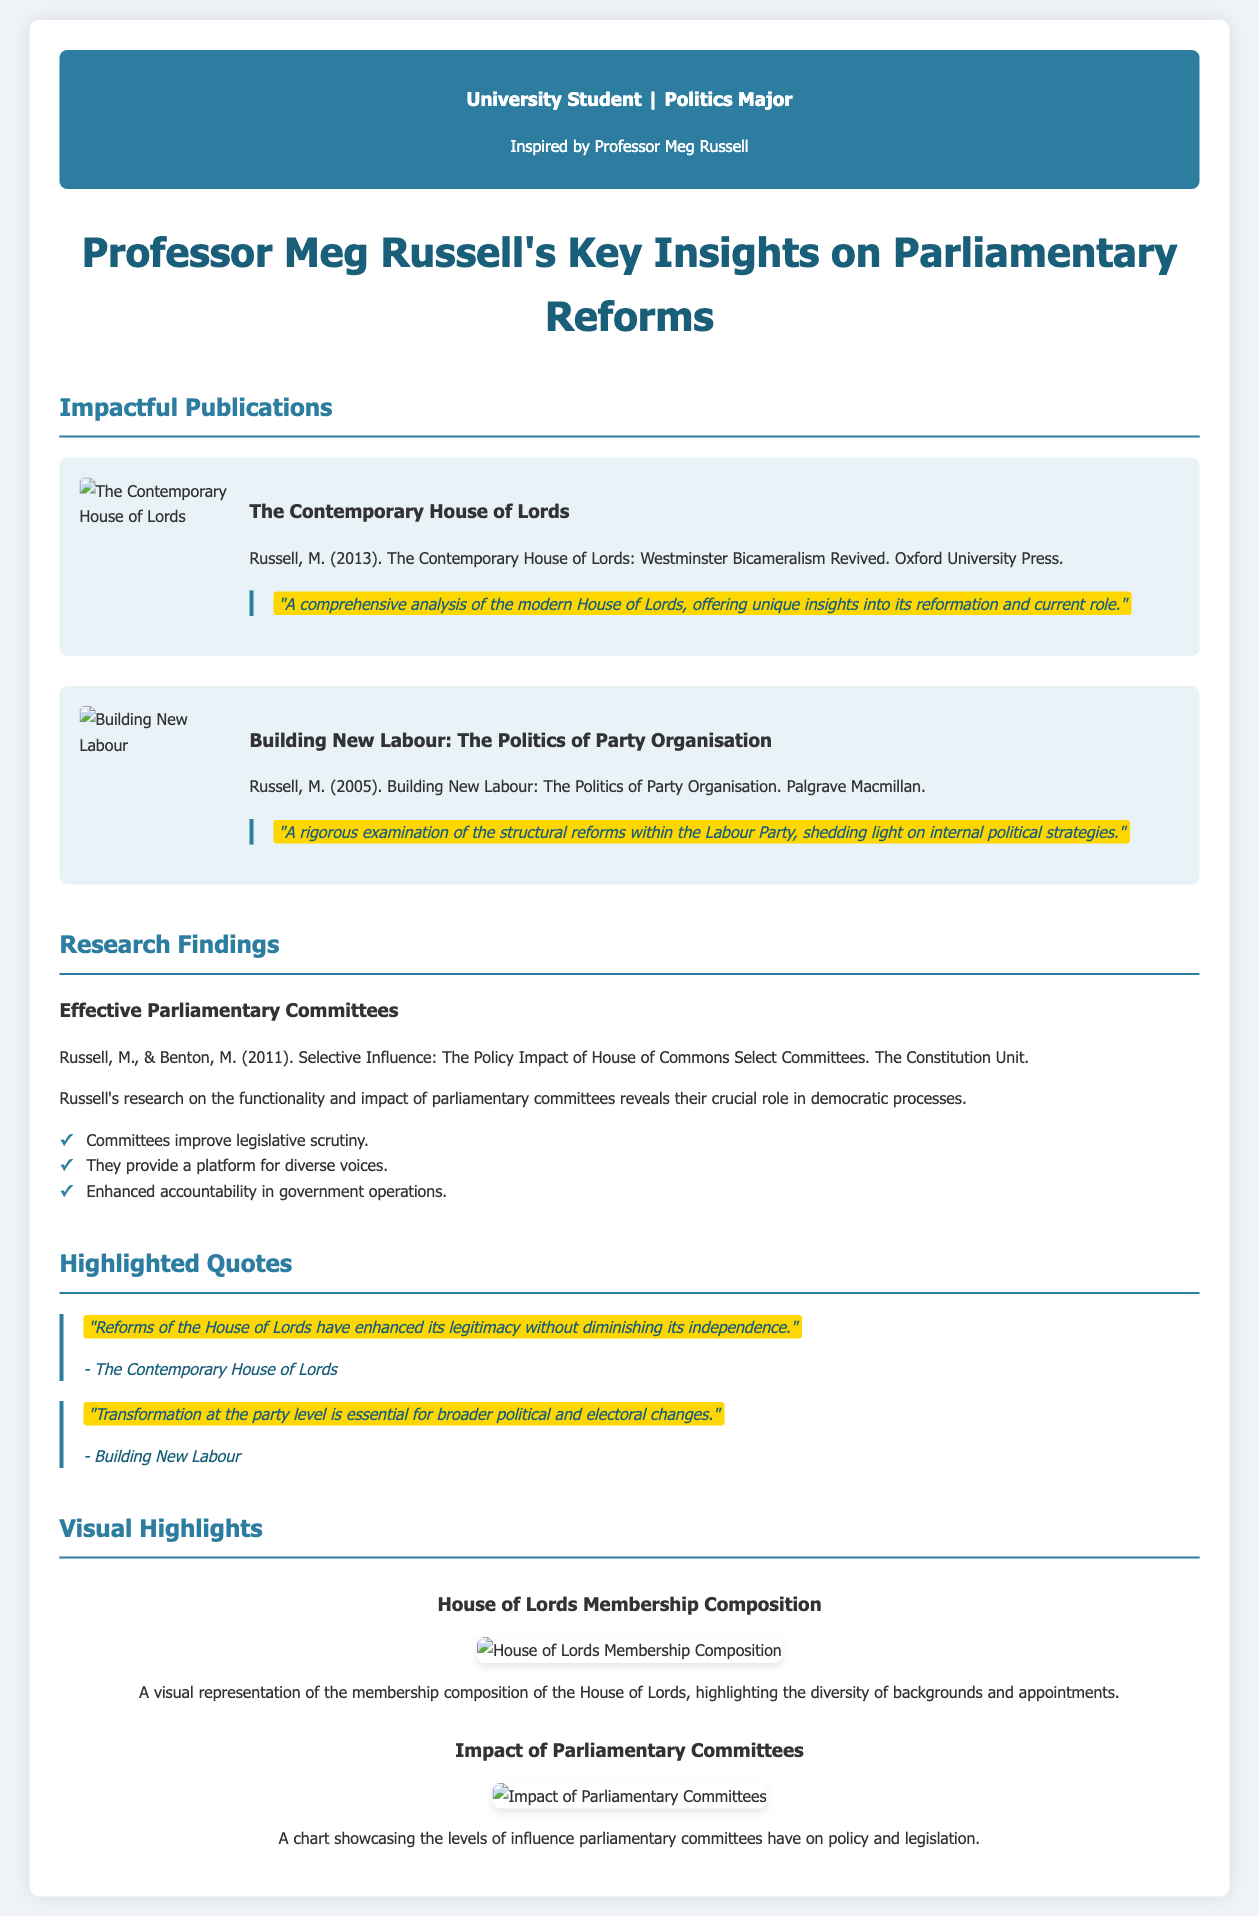What is the title of Meg Russell's 2013 publication? The title is listed in the document under impactful publications.
Answer: The Contemporary House of Lords Who is the co-author of the research on effective parliamentary committees? The document mentions her research along with another author.
Answer: Benton, M What year was "Building New Labour" published? The publication year is stated in the details of the document.
Answer: 2005 How many key insights are highlighted in the findings list regarding parliamentary committees? The document lists the specific insights as bullet points.
Answer: Three What is the main topic of Meg Russell's research on House of Commons Select Committees? The document describes the focus of her research in the overview.
Answer: Policy Impact Which visual demonstrates the House of Lords membership composition? The document identifies visual highlights and their content.
Answer: House of Lords Membership Composition According to her findings, what is one advantage of parliamentary committees? The document lists advantages, providing specific information.
Answer: Improved legislative scrutiny What is the publisher of "The Contemporary House of Lords"? The publishing information is provided in the details of the relevant publication.
Answer: Oxford University Press 